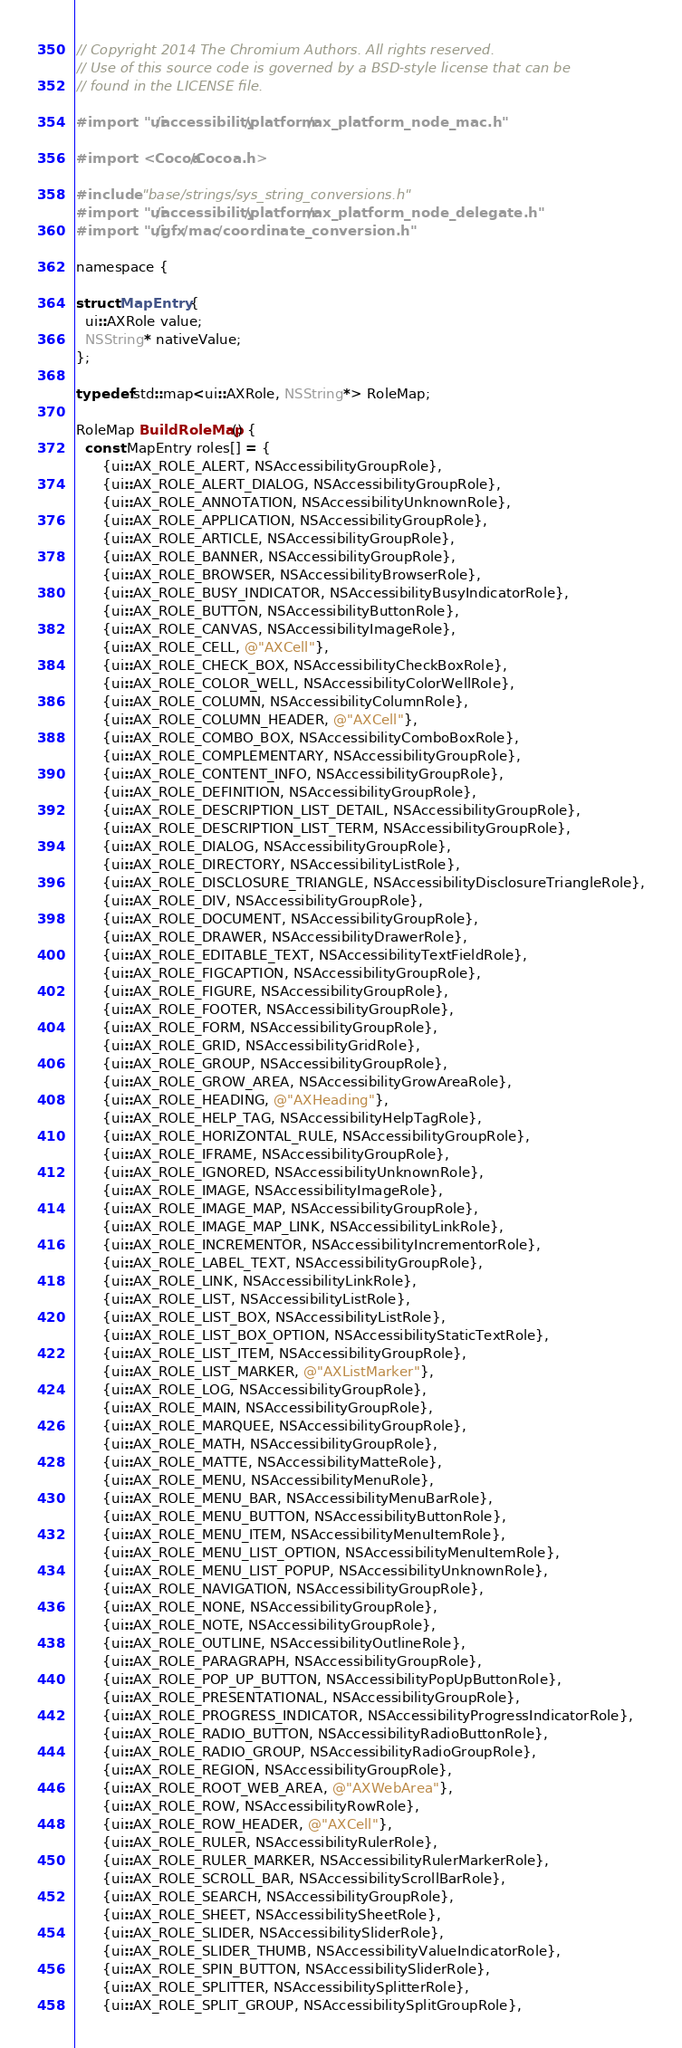Convert code to text. <code><loc_0><loc_0><loc_500><loc_500><_ObjectiveC_>// Copyright 2014 The Chromium Authors. All rights reserved.
// Use of this source code is governed by a BSD-style license that can be
// found in the LICENSE file.

#import "ui/accessibility/platform/ax_platform_node_mac.h"

#import <Cocoa/Cocoa.h>

#include "base/strings/sys_string_conversions.h"
#import "ui/accessibility/platform/ax_platform_node_delegate.h"
#import "ui/gfx/mac/coordinate_conversion.h"

namespace {

struct MapEntry {
  ui::AXRole value;
  NSString* nativeValue;
};

typedef std::map<ui::AXRole, NSString*> RoleMap;

RoleMap BuildRoleMap() {
  const MapEntry roles[] = {
      {ui::AX_ROLE_ALERT, NSAccessibilityGroupRole},
      {ui::AX_ROLE_ALERT_DIALOG, NSAccessibilityGroupRole},
      {ui::AX_ROLE_ANNOTATION, NSAccessibilityUnknownRole},
      {ui::AX_ROLE_APPLICATION, NSAccessibilityGroupRole},
      {ui::AX_ROLE_ARTICLE, NSAccessibilityGroupRole},
      {ui::AX_ROLE_BANNER, NSAccessibilityGroupRole},
      {ui::AX_ROLE_BROWSER, NSAccessibilityBrowserRole},
      {ui::AX_ROLE_BUSY_INDICATOR, NSAccessibilityBusyIndicatorRole},
      {ui::AX_ROLE_BUTTON, NSAccessibilityButtonRole},
      {ui::AX_ROLE_CANVAS, NSAccessibilityImageRole},
      {ui::AX_ROLE_CELL, @"AXCell"},
      {ui::AX_ROLE_CHECK_BOX, NSAccessibilityCheckBoxRole},
      {ui::AX_ROLE_COLOR_WELL, NSAccessibilityColorWellRole},
      {ui::AX_ROLE_COLUMN, NSAccessibilityColumnRole},
      {ui::AX_ROLE_COLUMN_HEADER, @"AXCell"},
      {ui::AX_ROLE_COMBO_BOX, NSAccessibilityComboBoxRole},
      {ui::AX_ROLE_COMPLEMENTARY, NSAccessibilityGroupRole},
      {ui::AX_ROLE_CONTENT_INFO, NSAccessibilityGroupRole},
      {ui::AX_ROLE_DEFINITION, NSAccessibilityGroupRole},
      {ui::AX_ROLE_DESCRIPTION_LIST_DETAIL, NSAccessibilityGroupRole},
      {ui::AX_ROLE_DESCRIPTION_LIST_TERM, NSAccessibilityGroupRole},
      {ui::AX_ROLE_DIALOG, NSAccessibilityGroupRole},
      {ui::AX_ROLE_DIRECTORY, NSAccessibilityListRole},
      {ui::AX_ROLE_DISCLOSURE_TRIANGLE, NSAccessibilityDisclosureTriangleRole},
      {ui::AX_ROLE_DIV, NSAccessibilityGroupRole},
      {ui::AX_ROLE_DOCUMENT, NSAccessibilityGroupRole},
      {ui::AX_ROLE_DRAWER, NSAccessibilityDrawerRole},
      {ui::AX_ROLE_EDITABLE_TEXT, NSAccessibilityTextFieldRole},
      {ui::AX_ROLE_FIGCAPTION, NSAccessibilityGroupRole},
      {ui::AX_ROLE_FIGURE, NSAccessibilityGroupRole},
      {ui::AX_ROLE_FOOTER, NSAccessibilityGroupRole},
      {ui::AX_ROLE_FORM, NSAccessibilityGroupRole},
      {ui::AX_ROLE_GRID, NSAccessibilityGridRole},
      {ui::AX_ROLE_GROUP, NSAccessibilityGroupRole},
      {ui::AX_ROLE_GROW_AREA, NSAccessibilityGrowAreaRole},
      {ui::AX_ROLE_HEADING, @"AXHeading"},
      {ui::AX_ROLE_HELP_TAG, NSAccessibilityHelpTagRole},
      {ui::AX_ROLE_HORIZONTAL_RULE, NSAccessibilityGroupRole},
      {ui::AX_ROLE_IFRAME, NSAccessibilityGroupRole},
      {ui::AX_ROLE_IGNORED, NSAccessibilityUnknownRole},
      {ui::AX_ROLE_IMAGE, NSAccessibilityImageRole},
      {ui::AX_ROLE_IMAGE_MAP, NSAccessibilityGroupRole},
      {ui::AX_ROLE_IMAGE_MAP_LINK, NSAccessibilityLinkRole},
      {ui::AX_ROLE_INCREMENTOR, NSAccessibilityIncrementorRole},
      {ui::AX_ROLE_LABEL_TEXT, NSAccessibilityGroupRole},
      {ui::AX_ROLE_LINK, NSAccessibilityLinkRole},
      {ui::AX_ROLE_LIST, NSAccessibilityListRole},
      {ui::AX_ROLE_LIST_BOX, NSAccessibilityListRole},
      {ui::AX_ROLE_LIST_BOX_OPTION, NSAccessibilityStaticTextRole},
      {ui::AX_ROLE_LIST_ITEM, NSAccessibilityGroupRole},
      {ui::AX_ROLE_LIST_MARKER, @"AXListMarker"},
      {ui::AX_ROLE_LOG, NSAccessibilityGroupRole},
      {ui::AX_ROLE_MAIN, NSAccessibilityGroupRole},
      {ui::AX_ROLE_MARQUEE, NSAccessibilityGroupRole},
      {ui::AX_ROLE_MATH, NSAccessibilityGroupRole},
      {ui::AX_ROLE_MATTE, NSAccessibilityMatteRole},
      {ui::AX_ROLE_MENU, NSAccessibilityMenuRole},
      {ui::AX_ROLE_MENU_BAR, NSAccessibilityMenuBarRole},
      {ui::AX_ROLE_MENU_BUTTON, NSAccessibilityButtonRole},
      {ui::AX_ROLE_MENU_ITEM, NSAccessibilityMenuItemRole},
      {ui::AX_ROLE_MENU_LIST_OPTION, NSAccessibilityMenuItemRole},
      {ui::AX_ROLE_MENU_LIST_POPUP, NSAccessibilityUnknownRole},
      {ui::AX_ROLE_NAVIGATION, NSAccessibilityGroupRole},
      {ui::AX_ROLE_NONE, NSAccessibilityGroupRole},
      {ui::AX_ROLE_NOTE, NSAccessibilityGroupRole},
      {ui::AX_ROLE_OUTLINE, NSAccessibilityOutlineRole},
      {ui::AX_ROLE_PARAGRAPH, NSAccessibilityGroupRole},
      {ui::AX_ROLE_POP_UP_BUTTON, NSAccessibilityPopUpButtonRole},
      {ui::AX_ROLE_PRESENTATIONAL, NSAccessibilityGroupRole},
      {ui::AX_ROLE_PROGRESS_INDICATOR, NSAccessibilityProgressIndicatorRole},
      {ui::AX_ROLE_RADIO_BUTTON, NSAccessibilityRadioButtonRole},
      {ui::AX_ROLE_RADIO_GROUP, NSAccessibilityRadioGroupRole},
      {ui::AX_ROLE_REGION, NSAccessibilityGroupRole},
      {ui::AX_ROLE_ROOT_WEB_AREA, @"AXWebArea"},
      {ui::AX_ROLE_ROW, NSAccessibilityRowRole},
      {ui::AX_ROLE_ROW_HEADER, @"AXCell"},
      {ui::AX_ROLE_RULER, NSAccessibilityRulerRole},
      {ui::AX_ROLE_RULER_MARKER, NSAccessibilityRulerMarkerRole},
      {ui::AX_ROLE_SCROLL_BAR, NSAccessibilityScrollBarRole},
      {ui::AX_ROLE_SEARCH, NSAccessibilityGroupRole},
      {ui::AX_ROLE_SHEET, NSAccessibilitySheetRole},
      {ui::AX_ROLE_SLIDER, NSAccessibilitySliderRole},
      {ui::AX_ROLE_SLIDER_THUMB, NSAccessibilityValueIndicatorRole},
      {ui::AX_ROLE_SPIN_BUTTON, NSAccessibilitySliderRole},
      {ui::AX_ROLE_SPLITTER, NSAccessibilitySplitterRole},
      {ui::AX_ROLE_SPLIT_GROUP, NSAccessibilitySplitGroupRole},</code> 